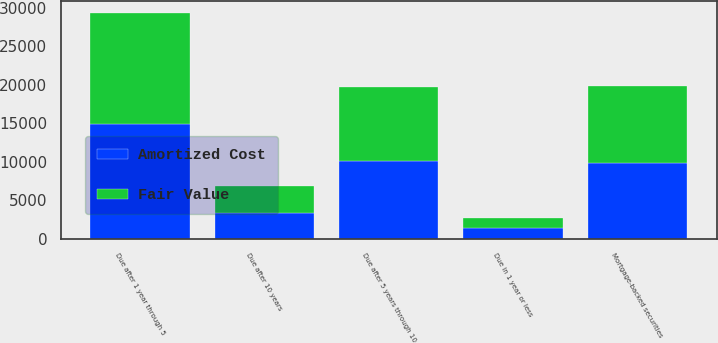Convert chart to OTSL. <chart><loc_0><loc_0><loc_500><loc_500><stacked_bar_chart><ecel><fcel>Due in 1 year or less<fcel>Due after 1 year through 5<fcel>Due after 5 years through 10<fcel>Due after 10 years<fcel>Mortgage-backed securities<nl><fcel>Fair Value<fcel>1354<fcel>14457<fcel>9642<fcel>3474<fcel>10058<nl><fcel>Amortized Cost<fcel>1352<fcel>14905<fcel>10067<fcel>3359<fcel>9842<nl></chart> 